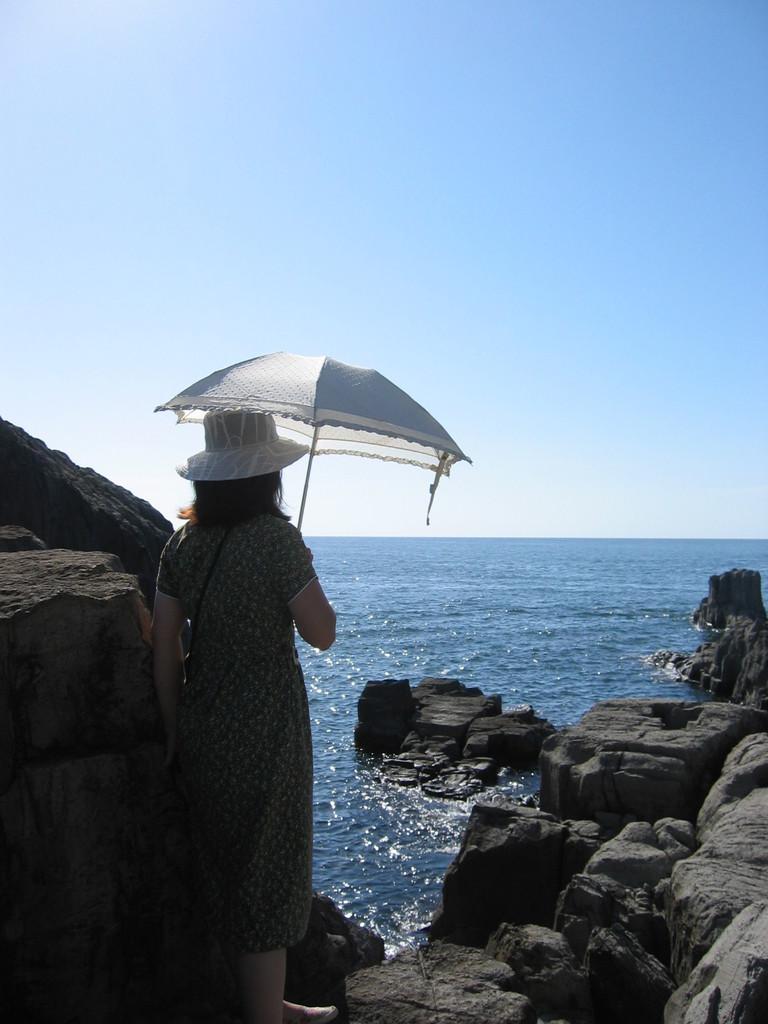Describe this image in one or two sentences. On the left side of this image I can see a woman wearing a frock, cap on the head, holding an umbrella in the hand and standing on the rock. In the background, I can see an ocean. At the top I can see the sky. 